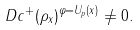<formula> <loc_0><loc_0><loc_500><loc_500>\ D c ^ { + } ( \rho _ { x } ) ^ { \varphi = U _ { p } ( x ) } \neq 0 .</formula> 